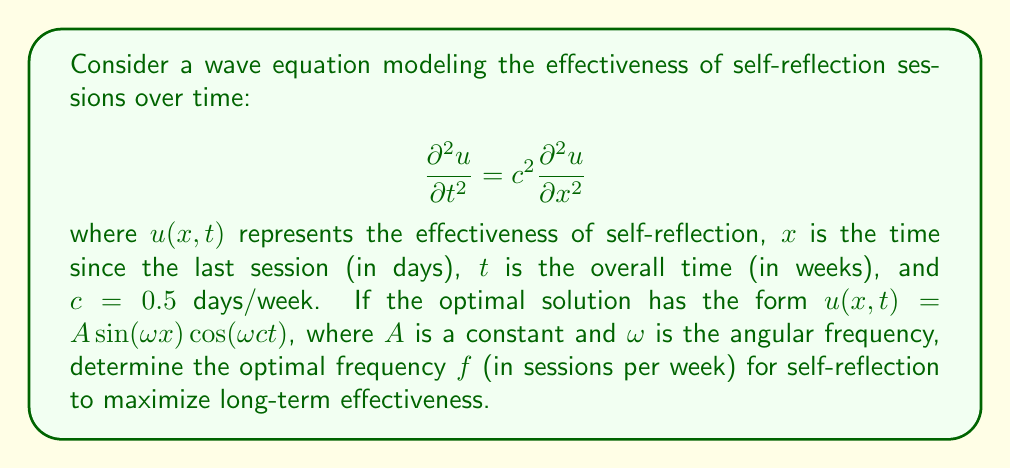Provide a solution to this math problem. To solve this problem, we'll follow these steps:

1) First, we need to understand that the given wave equation solution represents a standing wave. The optimal frequency will correspond to the fundamental mode of this standing wave.

2) For a standing wave, the relationship between angular frequency $\omega$ and the wave speed $c$ is:

   $$\omega = \frac{\pi c}{L}$$

   where $L$ is the length of the domain.

3) In this context, $L$ represents the optimal time between sessions. We want to find $f$, which is the inverse of $L$ when $L$ is measured in weeks.

4) We know that $c = 0.5$ days/week. We need to convert this to the same unit as $L$ (weeks):

   $$c = 0.5 \text{ days/week} = \frac{1}{14} \text{ weeks/week}$$

5) Now we can set up our equation:

   $$\omega = \frac{\pi c}{L} = \frac{\pi}{14L}$$

6) The frequency $f$ is related to $\omega$ by:

   $$f = \frac{\omega}{2\pi}$$

7) Substituting our expression for $\omega$:

   $$f = \frac{1}{28L}$$

8) Remember, $L$ is in weeks, and $f$ is the number of sessions per week. So:

   $$f = \frac{1}{28L} = \frac{1}{28} \cdot \frac{1}{L} = \frac{1}{28} \text{ sessions/week}$$

9) Converting to a more practical unit:

   $$f = \frac{1}{28} \text{ sessions/week} = \frac{1}{4} \text{ sessions/month}$$

This frequency aligns well with common self-development practices, suggesting monthly reflection sessions for optimal long-term effectiveness.
Answer: $\frac{1}{4}$ sessions per month 